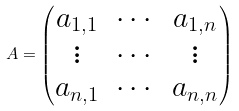<formula> <loc_0><loc_0><loc_500><loc_500>A = \begin{pmatrix} a _ { 1 , 1 } & \cdots & a _ { 1 , n } \\ \vdots & \cdots & \vdots \\ a _ { n , 1 } & \cdots & a _ { n , n } \end{pmatrix}</formula> 